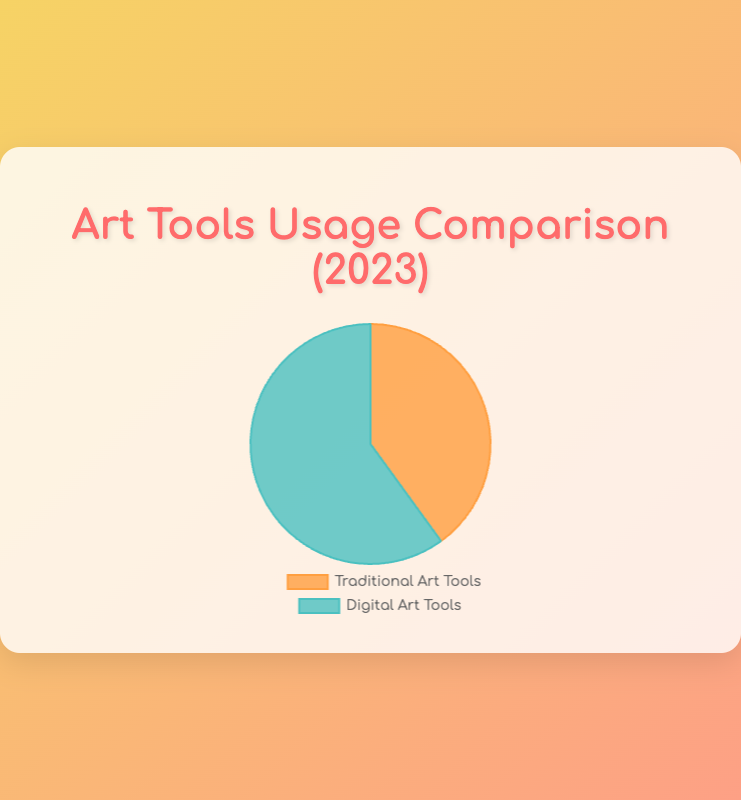Which category of art tools had a higher usage percentage in 2023? The figure shows two main categories: Traditional Art Tools and Digital Art Tools. By looking at the pie chart, we can see which segment occupies a larger portion of the pie. The Digital Art Tools segment is larger.
Answer: Digital Art Tools What percentage of the total art tools usage was dedicated to Traditional Art Tools in 2023? By looking at the pie chart, we can see the labeled percentage next to Traditional Art Tools, which shows 40%.
Answer: 40% How many percentage points greater is the usage of Digital Art Tools compared to Traditional Art Tools? The pie chart shows that Digital Art Tools have a usage percentage of 60%, and Traditional Art Tools have a usage percentage of 40%. The difference in percentage points is 60 - 40.
Answer: 20 percentage points Which visual attribute indicates the usage category for Digital Art Tools? The pie chart uses colors to denote different categories, with Digital Art Tools represented in a greenish-blue color.
Answer: Greenish-blue color What is the combined percentage usage of all art tools in 2023? The pie chart represents the comparison between Traditional and Digital Art Tools for the whole year. The sum of percentages for both categories is 40% + 60%.
Answer: 100% What proportion of art tool usage in 2023 was for Digital Art Tools? According to the pie chart, Digital Art Tools have a usage percentage of 60%. Therefore, the proportion is 60%.
Answer: 60% Which type of art tools had less usage in 2023, and by what percentage? The pie chart displays the usage percentages for Traditional Art Tools (40%) and Digital Art Tools (60%). Traditional Art Tools had less usage by 60 - 40 = 20%.
Answer: Traditional Art Tools, 20% How does the usage of Traditional Art Tools compare to the usage of Digital Art Tools in visual terms? Visually, the pie chart shows that the segment representing Traditional Art Tools is smaller than the segment representing Digital Art Tools, indicating a lesser usage percentage.
Answer: Smaller segment for Traditional Art Tools Between Traditional Art Tools and Digital Art Tools, which occupies a higher position in the legend of the pie chart? In the pie chart, the position of the segments in the legend can directly be viewed. Digital Art Tools usually appear after Traditional Art Tools in the legend based on the higher usage percentage.
Answer: Digital Art Tools What is the absolute difference in usage hours between the most-used digital tool and the most-used traditional tool? The most-used digital tool is Adobe Photoshop with 200 hours, and the most-used traditional tool is Graphite Pencils with 120 hours. The absolute difference is 200 - 120.
Answer: 80 hours 